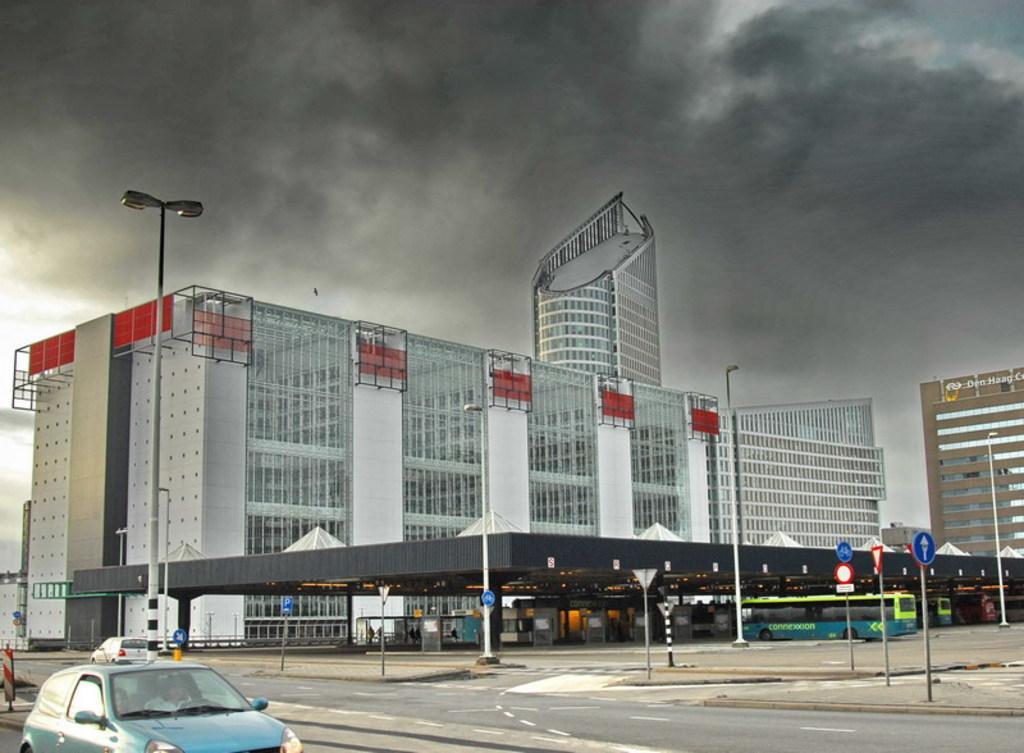Describe this image in one or two sentences. In this image I can see a empty road where we can see some cars and poles, beside that there is a building. 